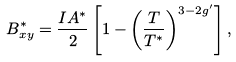Convert formula to latex. <formula><loc_0><loc_0><loc_500><loc_500>B _ { x y } ^ { * } = \frac { I A ^ { * } } { 2 } \left [ 1 - \left ( \frac { T } { T ^ { * } } \right ) ^ { 3 - 2 g ^ { \prime } } \right ] ,</formula> 